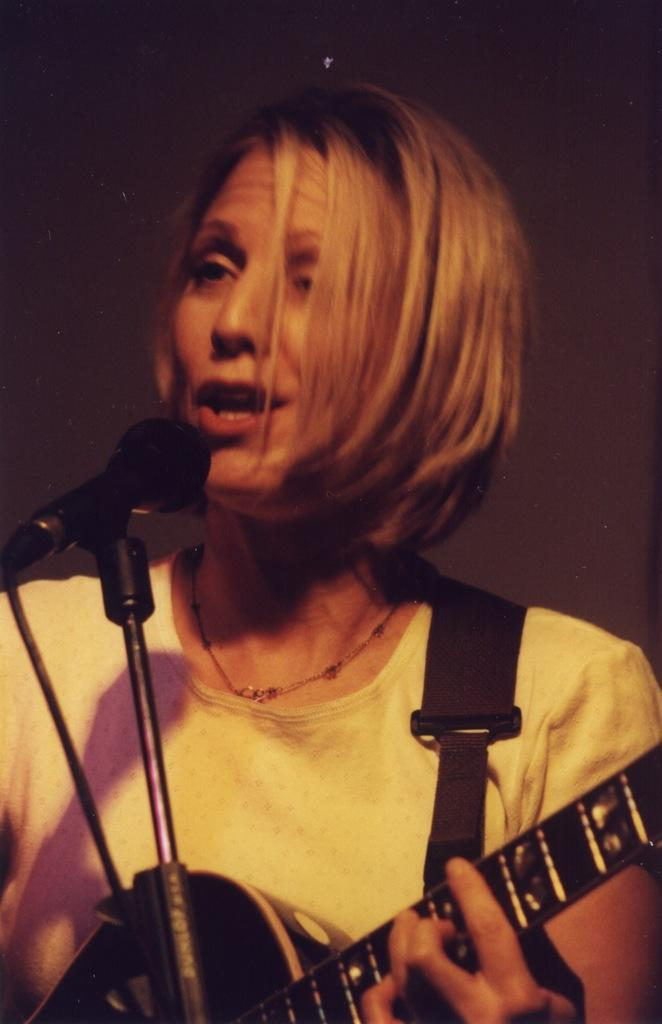Who is the main subject in the picture? There is a woman in the picture. What is the woman doing in the image? The woman is singing. What instrument is the woman holding in the image? The woman is holding a guitar. What device is the woman using to amplify her voice? The woman is using a microphone. Can you see a pig wearing underwear in the image? No, there is no pig or underwear present in the image. 